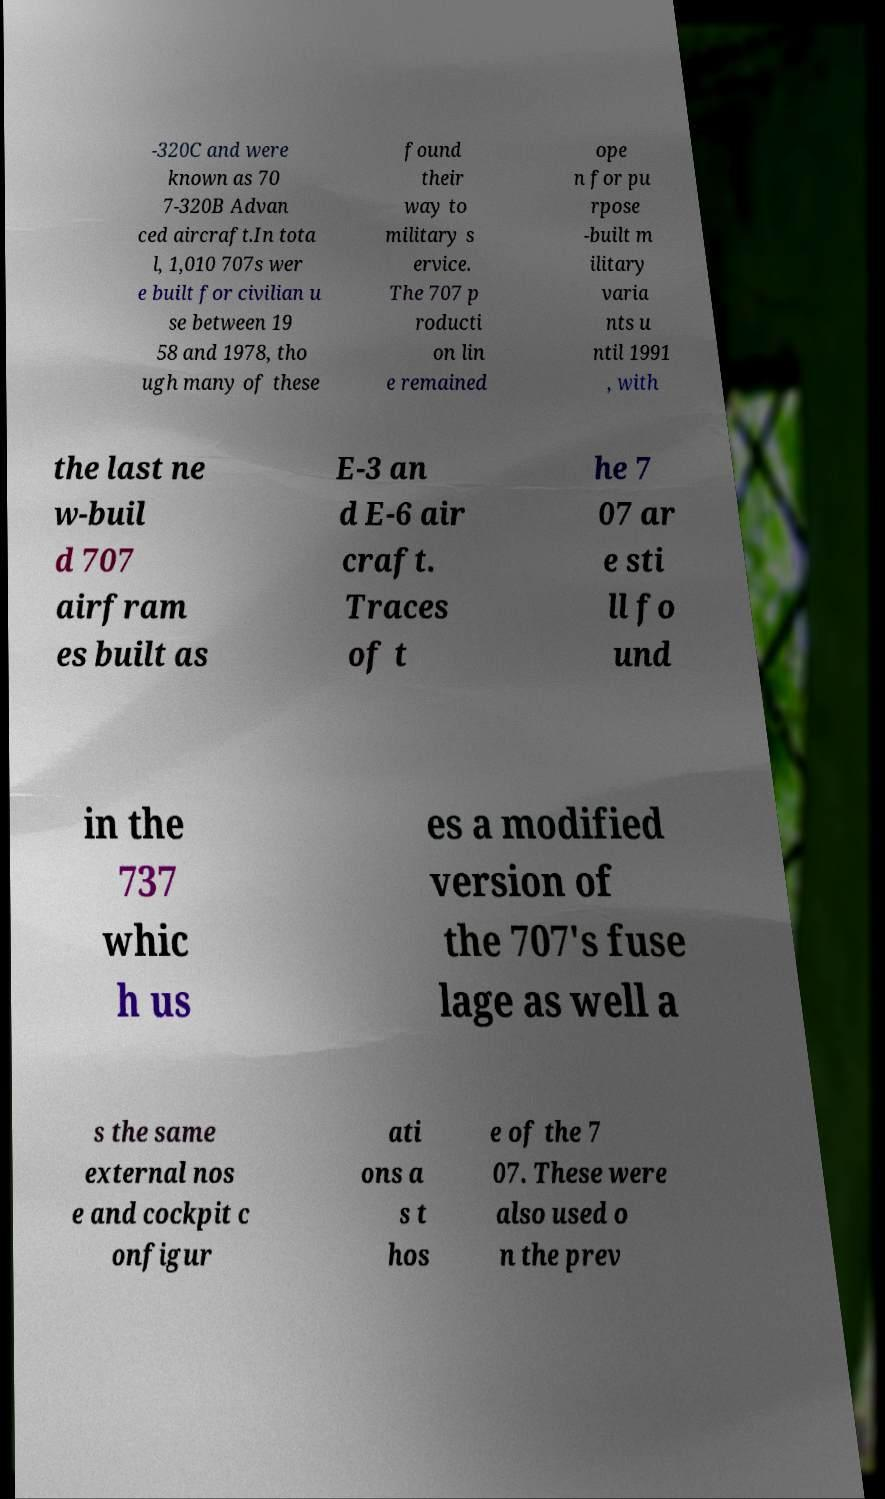Could you assist in decoding the text presented in this image and type it out clearly? -320C and were known as 70 7-320B Advan ced aircraft.In tota l, 1,010 707s wer e built for civilian u se between 19 58 and 1978, tho ugh many of these found their way to military s ervice. The 707 p roducti on lin e remained ope n for pu rpose -built m ilitary varia nts u ntil 1991 , with the last ne w-buil d 707 airfram es built as E-3 an d E-6 air craft. Traces of t he 7 07 ar e sti ll fo und in the 737 whic h us es a modified version of the 707's fuse lage as well a s the same external nos e and cockpit c onfigur ati ons a s t hos e of the 7 07. These were also used o n the prev 